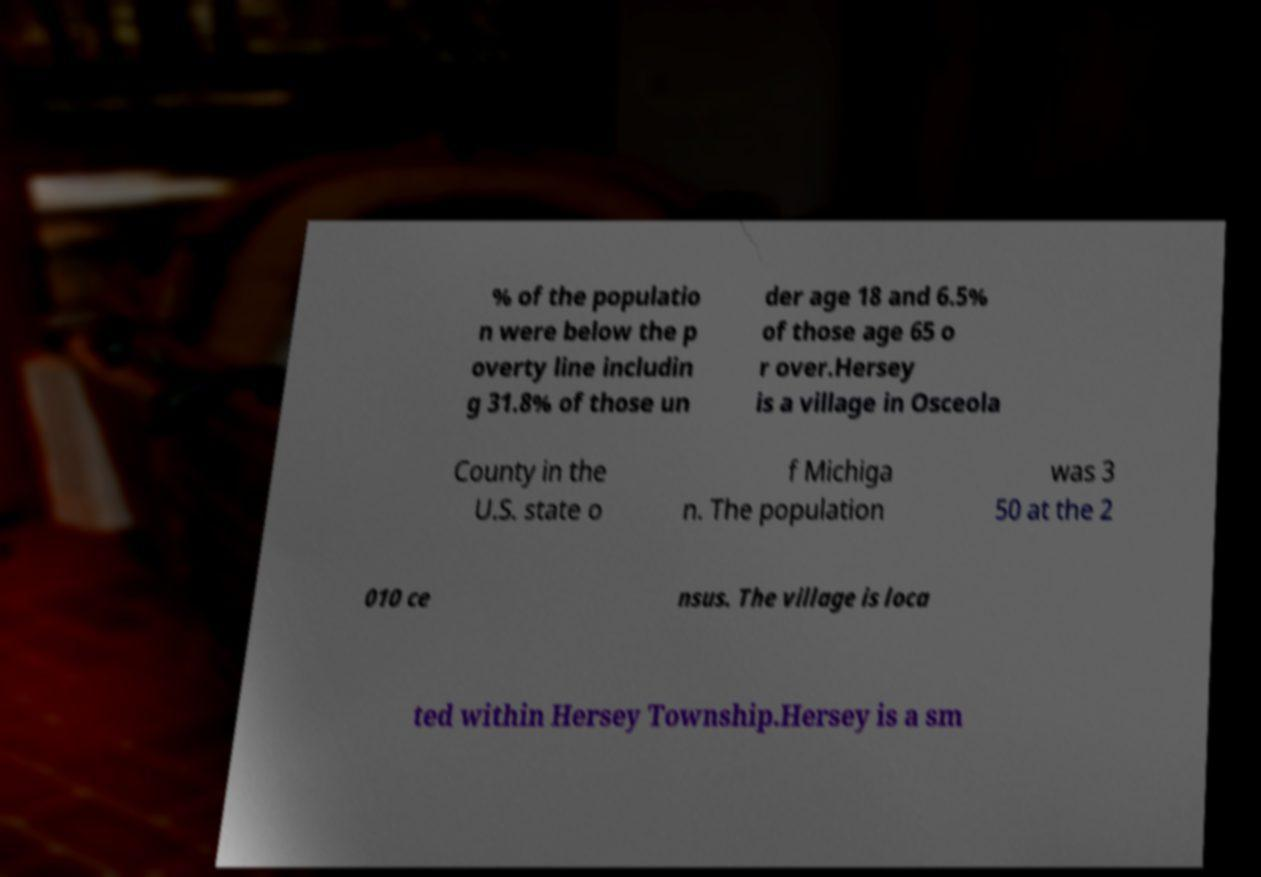Can you accurately transcribe the text from the provided image for me? % of the populatio n were below the p overty line includin g 31.8% of those un der age 18 and 6.5% of those age 65 o r over.Hersey is a village in Osceola County in the U.S. state o f Michiga n. The population was 3 50 at the 2 010 ce nsus. The village is loca ted within Hersey Township.Hersey is a sm 